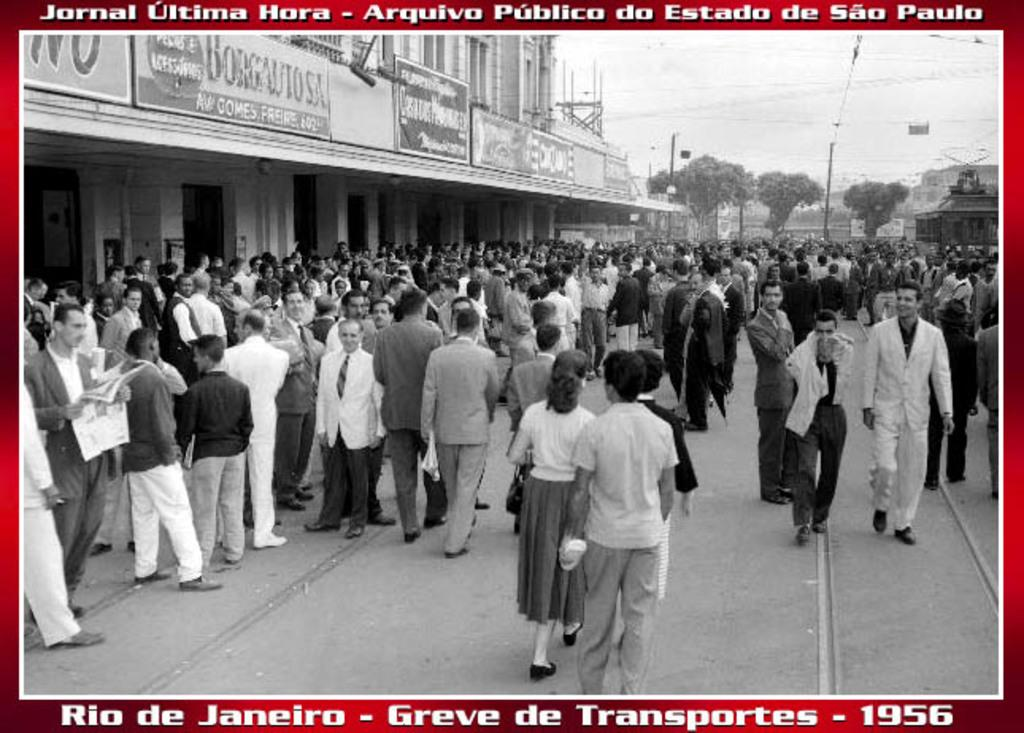<image>
Describe the image concisely. Event taking place in 1956 showing people on a street. 